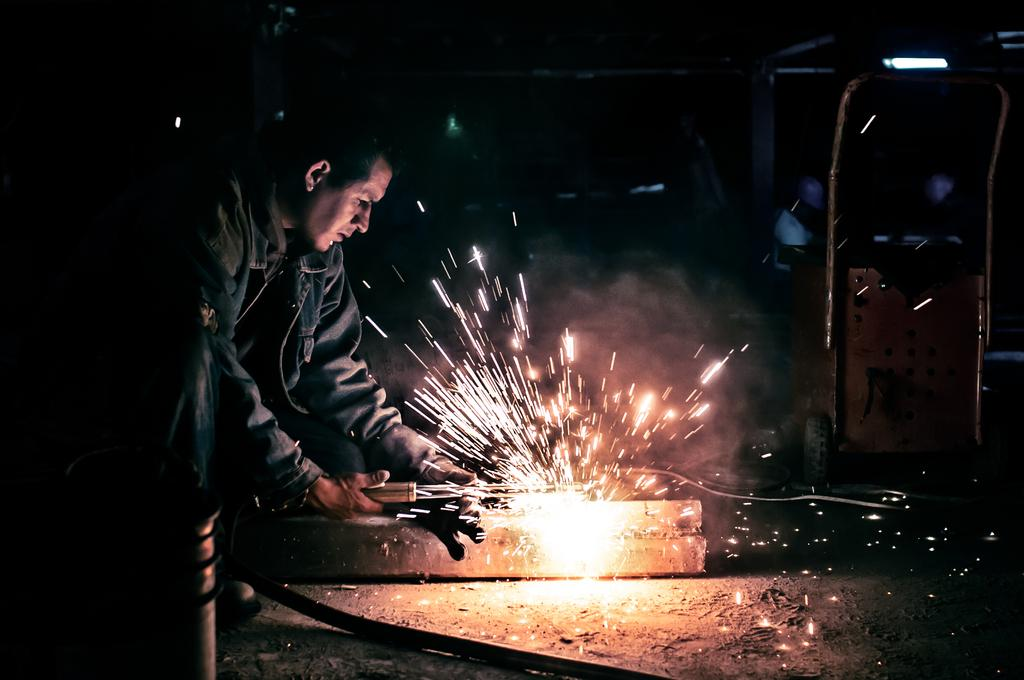What is the person in the image doing? The person is doing welding work. What is the person working on in the image? The person is working on a block, as seen in the image. What can be seen in the image that provides illumination? There are lights visible in the image. What is the person using to support the block while working on it? There is a stand in the image that the person is using to support the block. What other objects can be seen in the image besides the block, stand, and lights? There are other objects present in the image, but their specific details are not mentioned in the provided facts. What time of day is it in the image, based on the presence of a pocket watch? There is no pocket watch present in the image, so it is not possible to determine the time of day based on this information. 